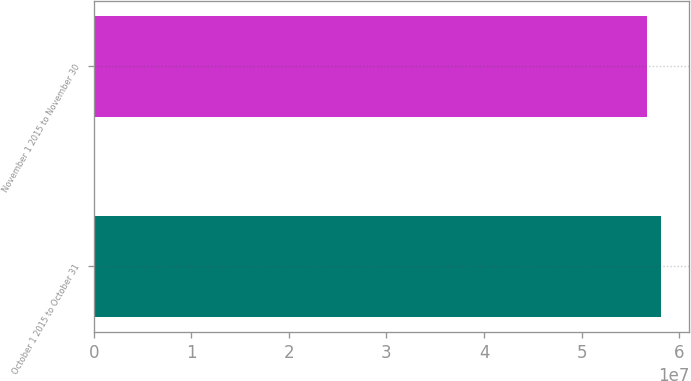Convert chart. <chart><loc_0><loc_0><loc_500><loc_500><bar_chart><fcel>October 1 2015 to October 31<fcel>November 1 2015 to November 30<nl><fcel>5.81104e+07<fcel>5.66694e+07<nl></chart> 